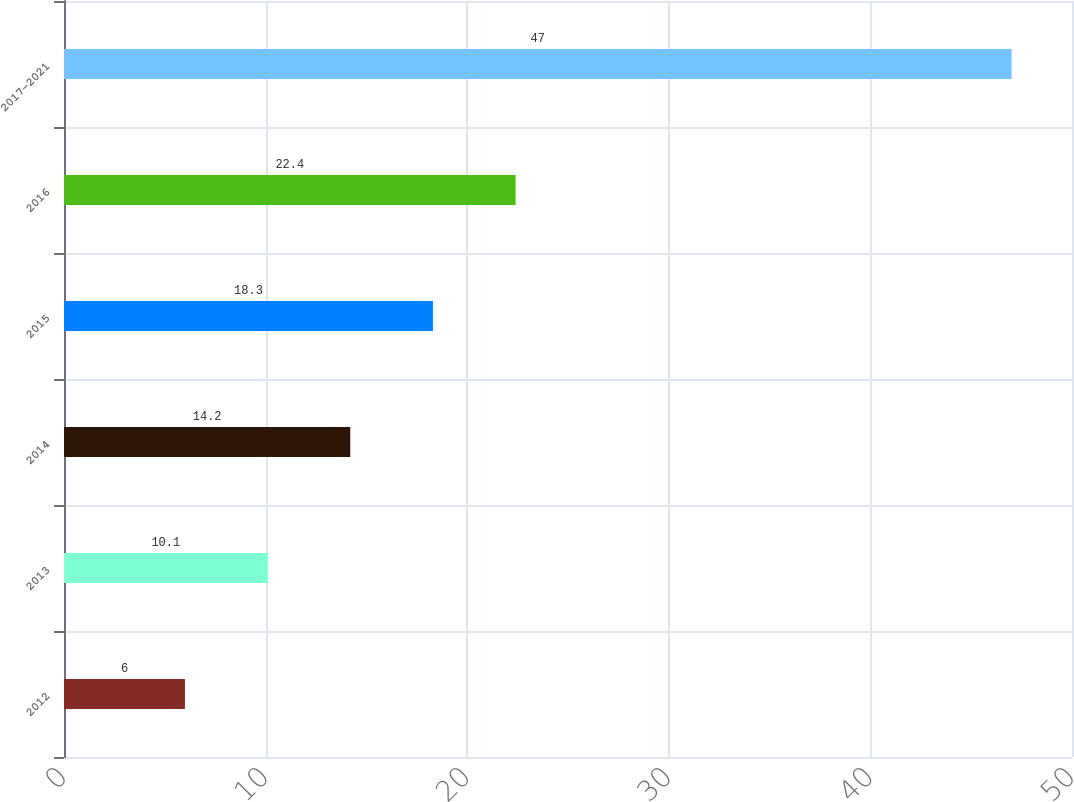Convert chart. <chart><loc_0><loc_0><loc_500><loc_500><bar_chart><fcel>2012<fcel>2013<fcel>2014<fcel>2015<fcel>2016<fcel>2017-2021<nl><fcel>6<fcel>10.1<fcel>14.2<fcel>18.3<fcel>22.4<fcel>47<nl></chart> 